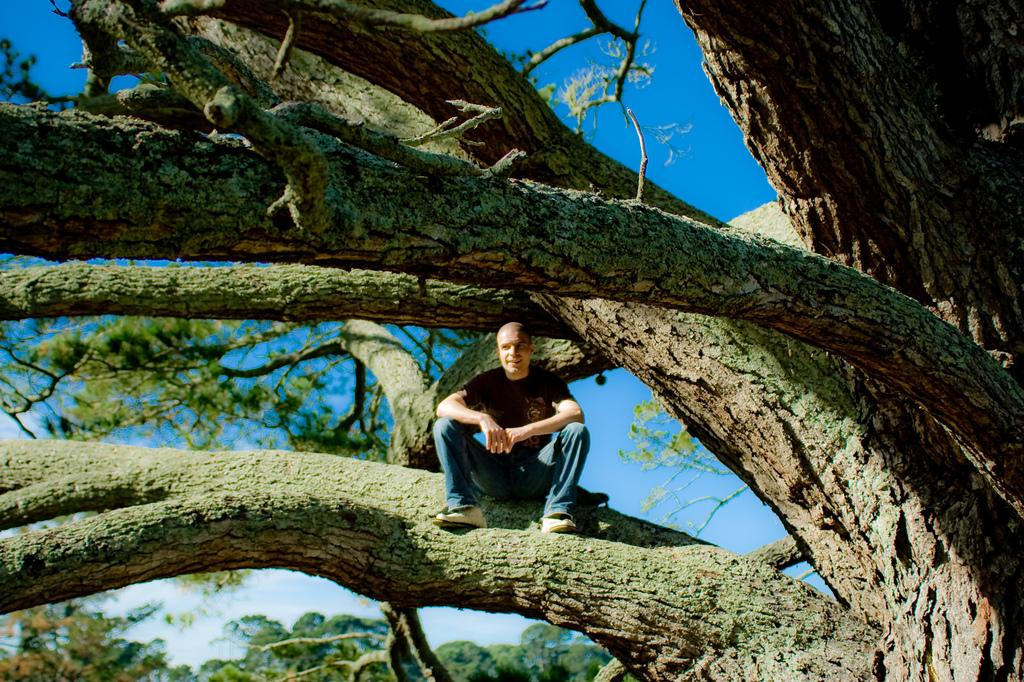What is the man in the image doing? The man is sitting on a tree in the image. Where is the man located in the image? The man is in the middle of the image. What can be seen behind the man? There is sky visible behind the man. What type of vegetation is present at the bottom left side of the image? There are trees at the bottom left side of the image. How many crayons can be seen in the hands of the children in the image? There are no children or crayons present in the image. 